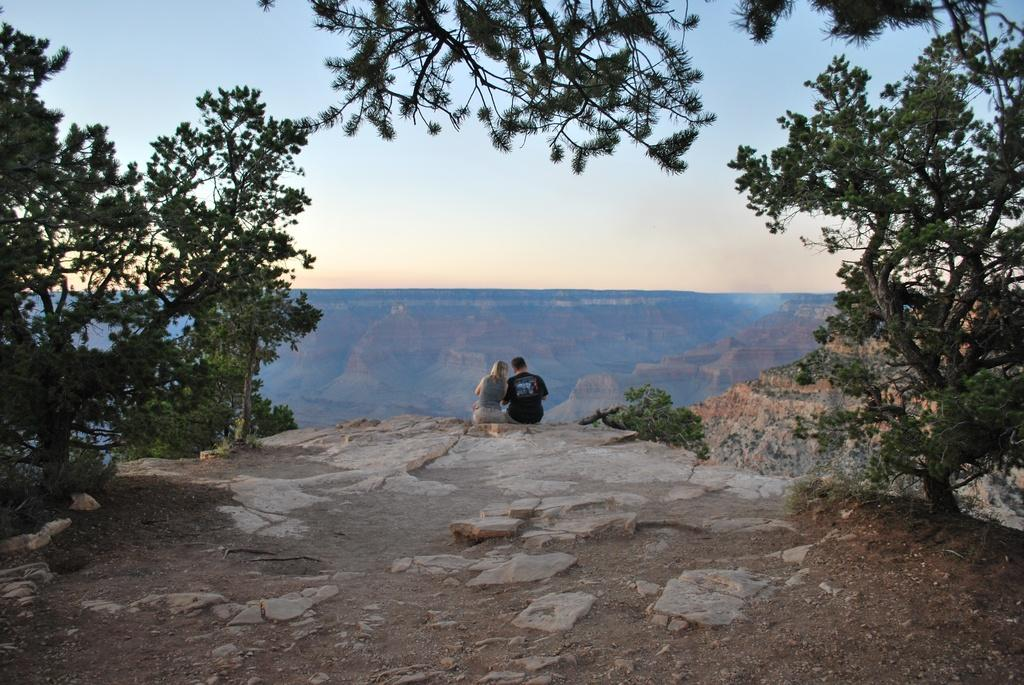Who is present in the image? There is a couple in the image. What are they doing in the image? The couple is sitting on a hill. What can be seen on the left side of the image? There are trees on the left side of the image. What can be seen on the right side of the image? There are trees on the right side of the image. What is visible in the background of the image? There are hills and the sky visible in the background of the image. What type of payment is being made by the farmer at the seashore in the image? There is no farmer or seashore present in the image; it features a couple sitting on a hill. 